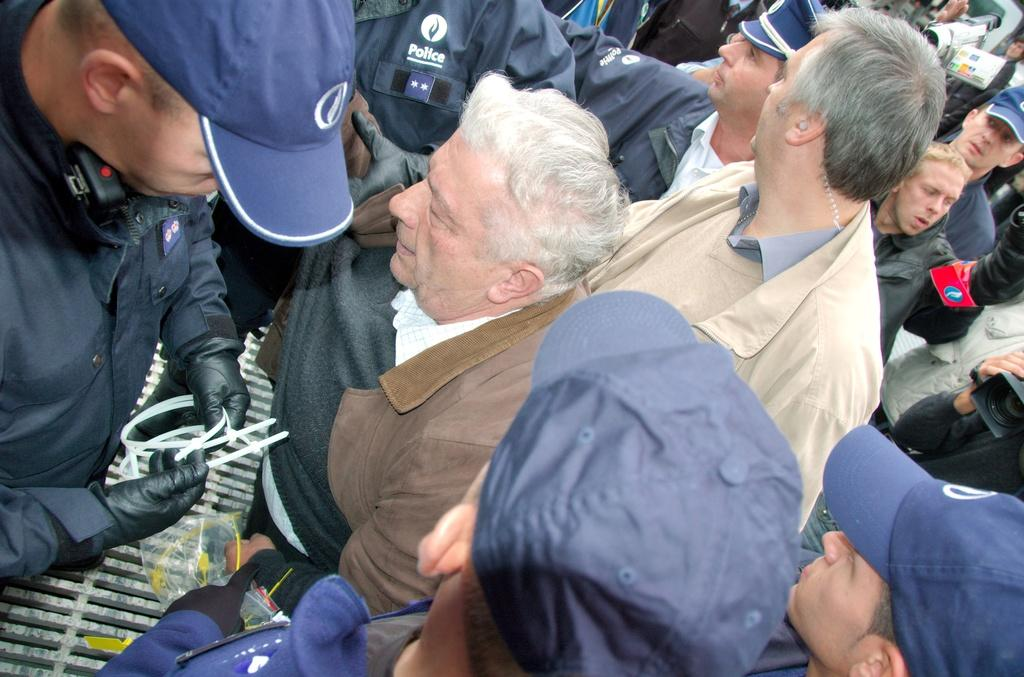How many people are in the image? There are multiple people in the image. What type of clothing are most of the people wearing? Most of the people are wearing jackets. Are there any accessories visible on the people in the image? Yes, some people are wearing caps. What objects can be seen in the image that are related to capturing images? There are cameras visible in the image. Can you see a hole in the image that people are trying to fill with a sponge? There is no hole or sponge present in the image. 